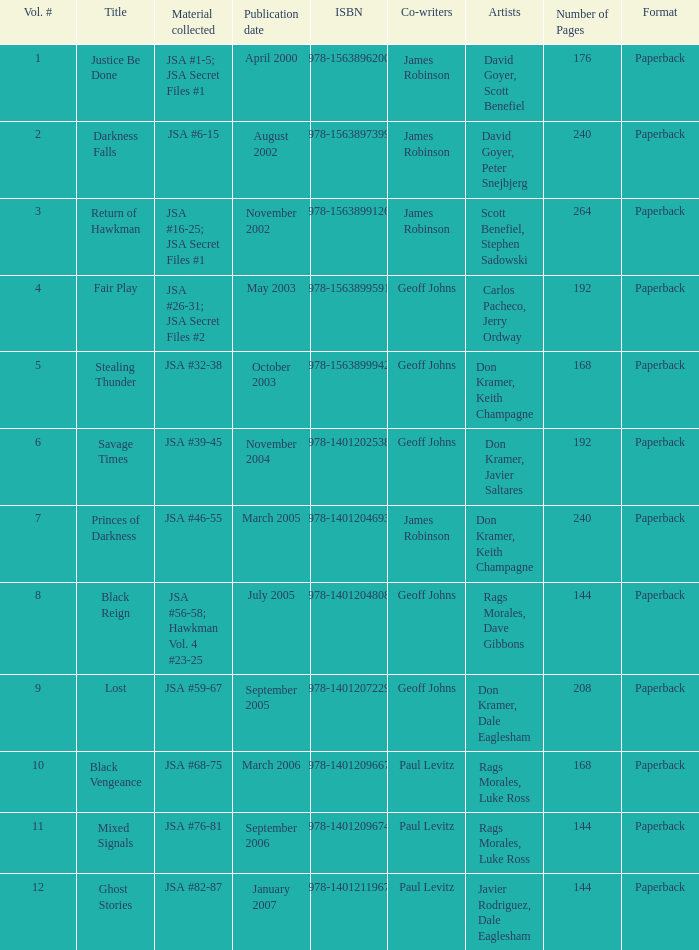Help me parse the entirety of this table. {'header': ['Vol. #', 'Title', 'Material collected', 'Publication date', 'ISBN', 'Co-writers', 'Artists', 'Number of Pages', 'Format'], 'rows': [['1', 'Justice Be Done', 'JSA #1-5; JSA Secret Files #1', 'April 2000', '978-1563896200', 'James Robinson', 'David Goyer, Scott Benefiel', '176', 'Paperback'], ['2', 'Darkness Falls', 'JSA #6-15', 'August 2002', '978-1563897399', 'James Robinson', 'David Goyer, Peter Snejbjerg', '240', 'Paperback'], ['3', 'Return of Hawkman', 'JSA #16-25; JSA Secret Files #1', 'November 2002', '978-1563899126', 'James Robinson', 'Scott Benefiel, Stephen Sadowski', '264', 'Paperback'], ['4', 'Fair Play', 'JSA #26-31; JSA Secret Files #2', 'May 2003', '978-1563899591', 'Geoff Johns', 'Carlos Pacheco, Jerry Ordway', '192', 'Paperback'], ['5', 'Stealing Thunder', 'JSA #32-38', 'October 2003', '978-1563899942', 'Geoff Johns', 'Don Kramer, Keith Champagne', '168', 'Paperback'], ['6', 'Savage Times', 'JSA #39-45', 'November 2004', '978-1401202538', 'Geoff Johns', 'Don Kramer, Javier Saltares', '192', 'Paperback'], ['7', 'Princes of Darkness', 'JSA #46-55', 'March 2005', '978-1401204693', 'James Robinson', 'Don Kramer, Keith Champagne', '240', 'Paperback'], ['8', 'Black Reign', 'JSA #56-58; Hawkman Vol. 4 #23-25', 'July 2005', '978-1401204808', 'Geoff Johns', 'Rags Morales, Dave Gibbons', '144', 'Paperback'], ['9', 'Lost', 'JSA #59-67', 'September 2005', '978-1401207229', 'Geoff Johns', 'Don Kramer, Dale Eaglesham', '208', 'Paperback'], ['10', 'Black Vengeance', 'JSA #68-75', 'March 2006', '978-1401209667', 'Paul Levitz', 'Rags Morales, Luke Ross', '168', 'Paperback'], ['11', 'Mixed Signals', 'JSA #76-81', 'September 2006', '978-1401209674', 'Paul Levitz', 'Rags Morales, Luke Ross', '144', 'Paperback'], ['12', 'Ghost Stories', 'JSA #82-87', 'January 2007', '978-1401211967', 'Paul Levitz', 'Javier Rodriguez, Dale Eaglesham', '144', 'Paperback']]} What's the Lowest Volume Number that was published November 2004? 6.0. 